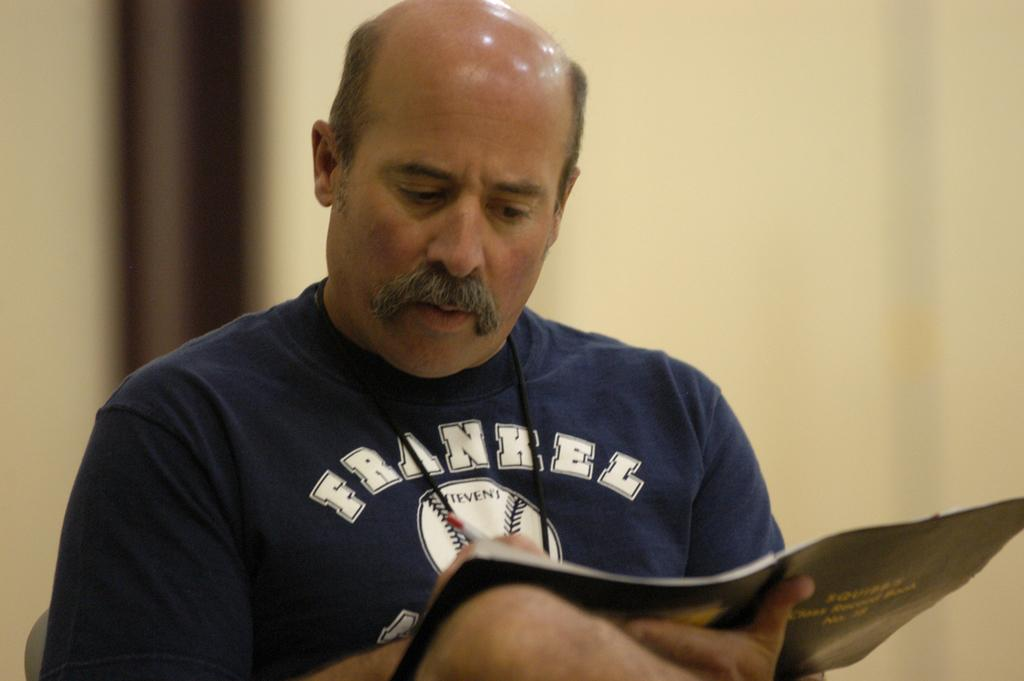<image>
Write a terse but informative summary of the picture. The man is wearing a blue shirt, on the front is a baseball that says Stevens. 